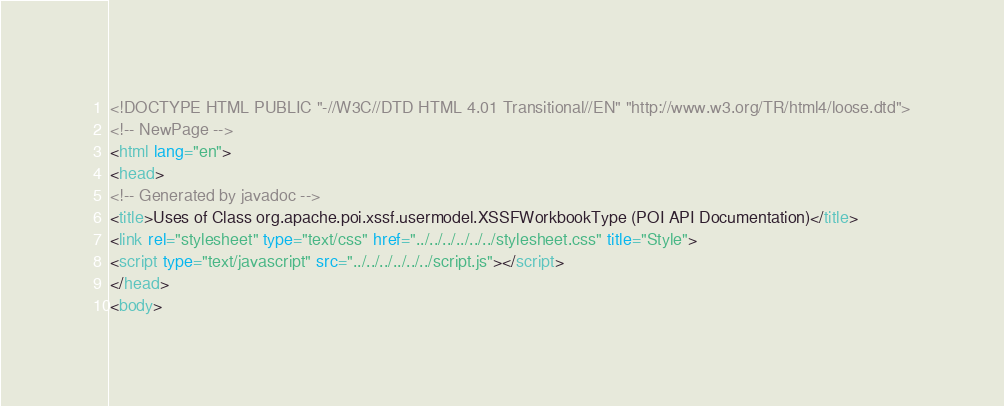<code> <loc_0><loc_0><loc_500><loc_500><_HTML_><!DOCTYPE HTML PUBLIC "-//W3C//DTD HTML 4.01 Transitional//EN" "http://www.w3.org/TR/html4/loose.dtd">
<!-- NewPage -->
<html lang="en">
<head>
<!-- Generated by javadoc -->
<title>Uses of Class org.apache.poi.xssf.usermodel.XSSFWorkbookType (POI API Documentation)</title>
<link rel="stylesheet" type="text/css" href="../../../../../../stylesheet.css" title="Style">
<script type="text/javascript" src="../../../../../../script.js"></script>
</head>
<body></code> 